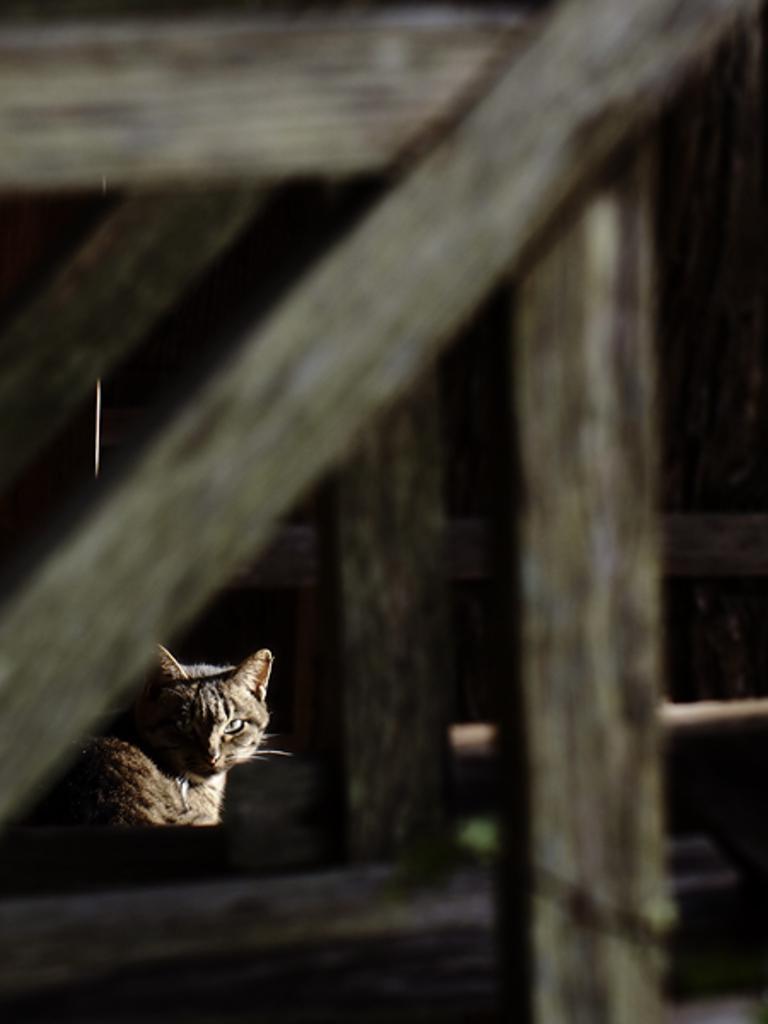In one or two sentences, can you explain what this image depicts? Here in this picture we can see a cat present over there and we can see wooden frames present beside it. 